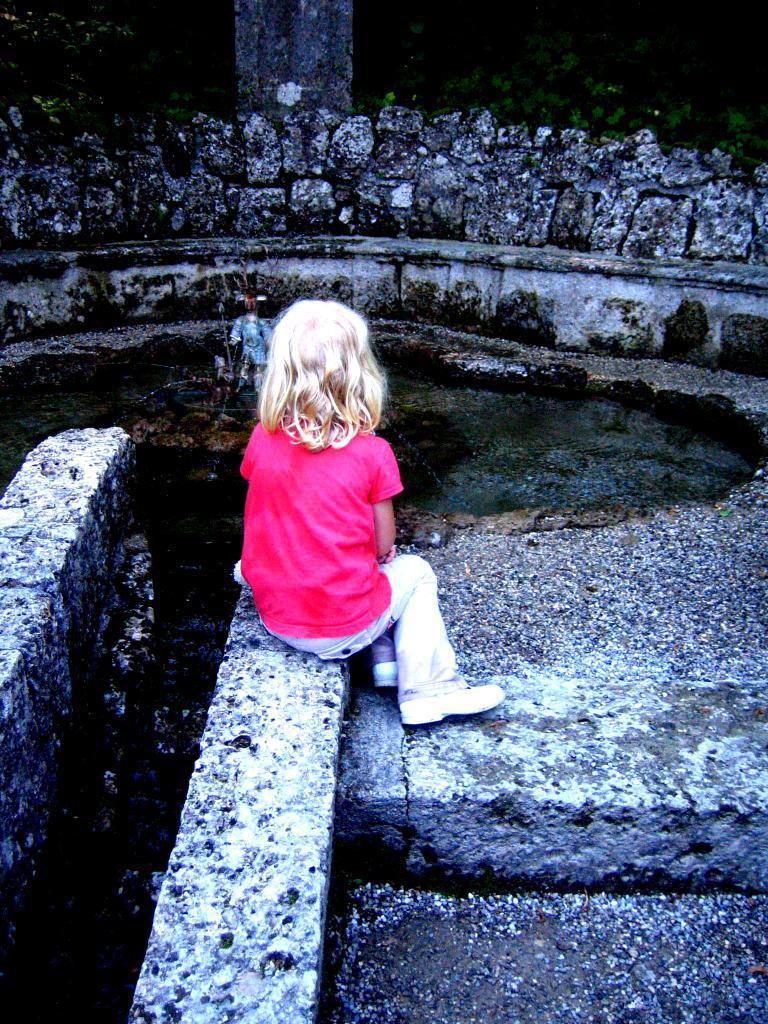Could you give a brief overview of what you see in this image? In this image, we can see a girl is sitting on the wall. Here we can see some objects. Top of the image, we can see few plants. 